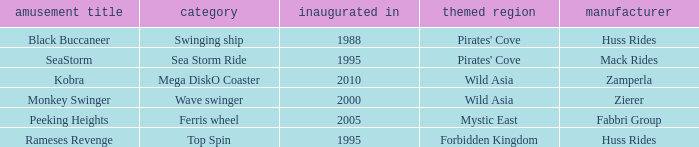What type of attraction is wild asia, which was inaugurated in 2000? Wave swinger. 